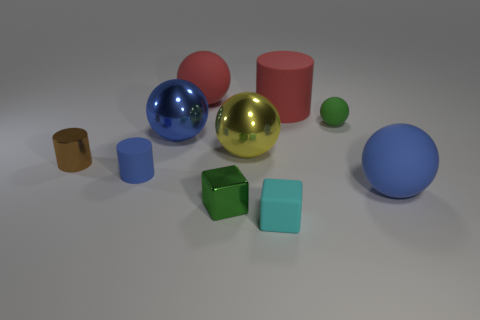Subtract 1 balls. How many balls are left? 4 Subtract all cylinders. How many objects are left? 7 Add 2 tiny red rubber spheres. How many tiny red rubber spheres exist? 2 Subtract 1 green balls. How many objects are left? 9 Subtract all small yellow objects. Subtract all yellow objects. How many objects are left? 9 Add 8 big matte cylinders. How many big matte cylinders are left? 9 